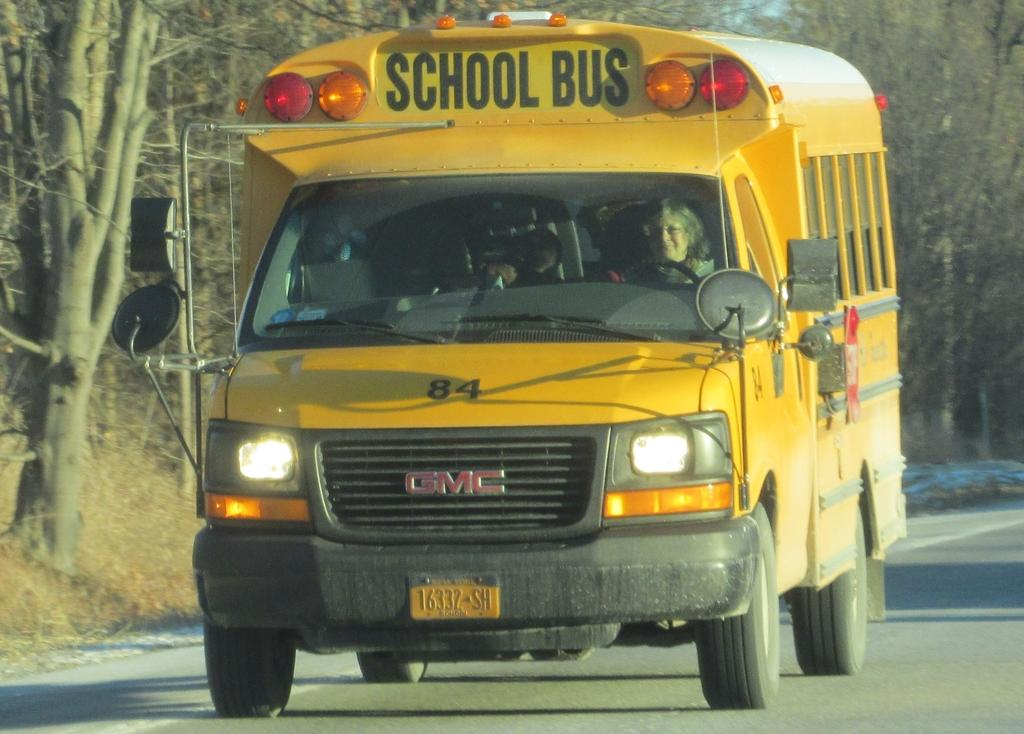<image>
Present a compact description of the photo's key features. A GMC brand school bus drives down the road. 